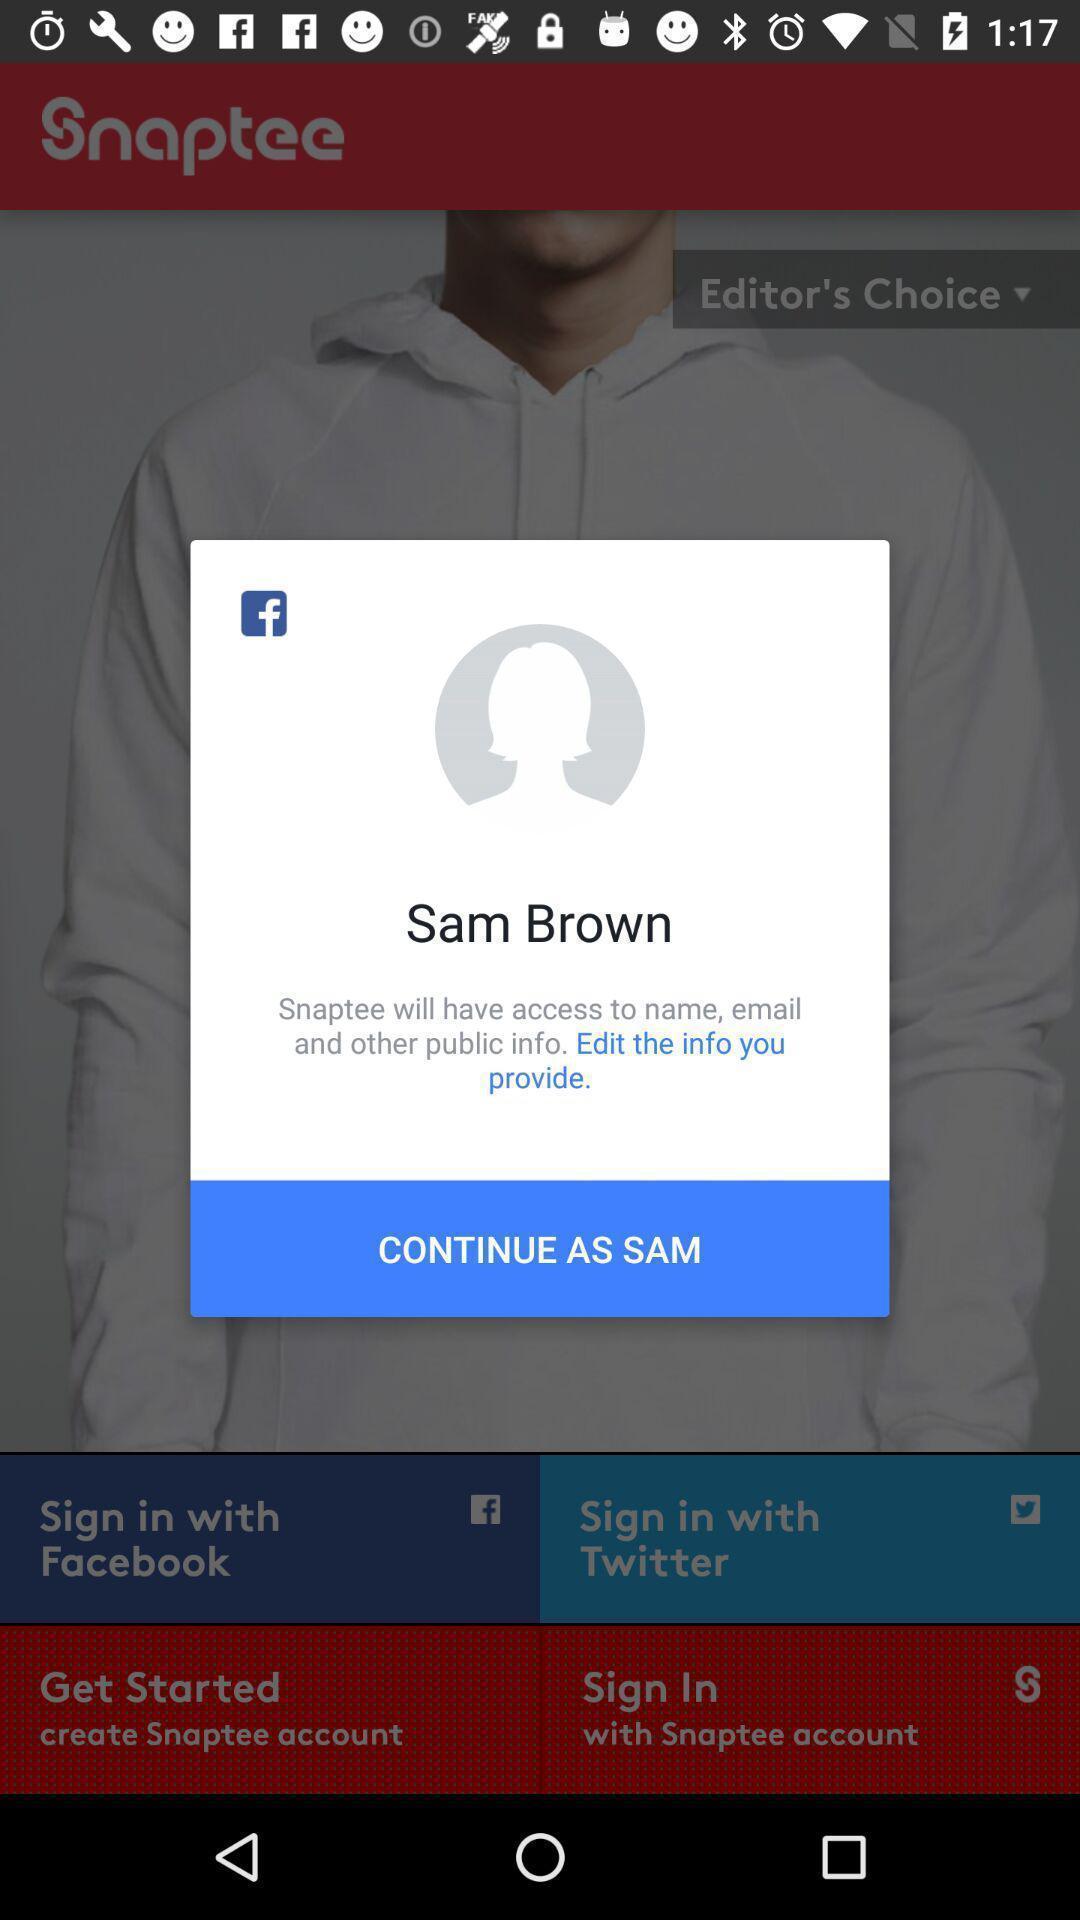Summarize the main components in this picture. Pop-up showing social application icons with continue as sam. 